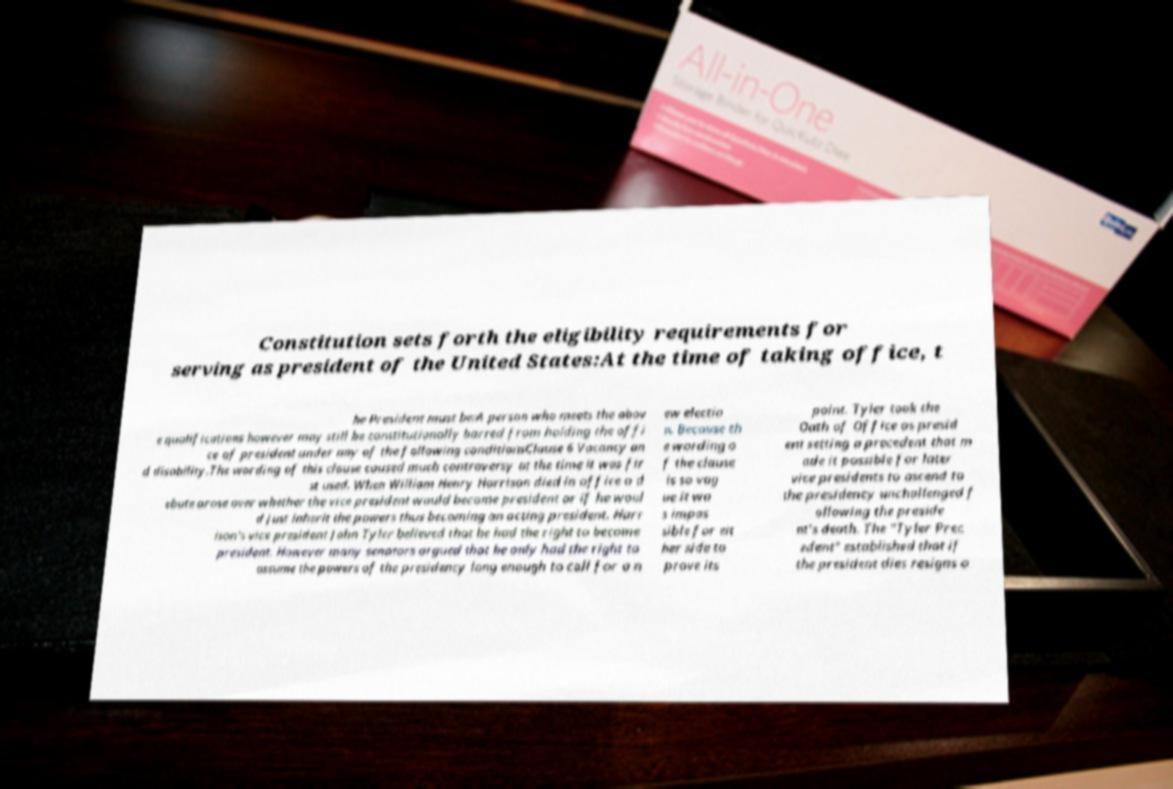What messages or text are displayed in this image? I need them in a readable, typed format. Constitution sets forth the eligibility requirements for serving as president of the United States:At the time of taking office, t he President must be:A person who meets the abov e qualifications however may still be constitutionally barred from holding the offi ce of president under any of the following conditionsClause 6 Vacancy an d disability.The wording of this clause caused much controversy at the time it was fir st used. When William Henry Harrison died in office a d ebate arose over whether the vice president would become president or if he woul d just inherit the powers thus becoming an acting president. Harr ison's vice president John Tyler believed that he had the right to become president. However many senators argued that he only had the right to assume the powers of the presidency long enough to call for a n ew electio n. Because th e wording o f the clause is so vag ue it wa s impos sible for eit her side to prove its point. Tyler took the Oath of Office as presid ent setting a precedent that m ade it possible for later vice presidents to ascend to the presidency unchallenged f ollowing the preside nt's death. The "Tyler Prec edent" established that if the president dies resigns o 